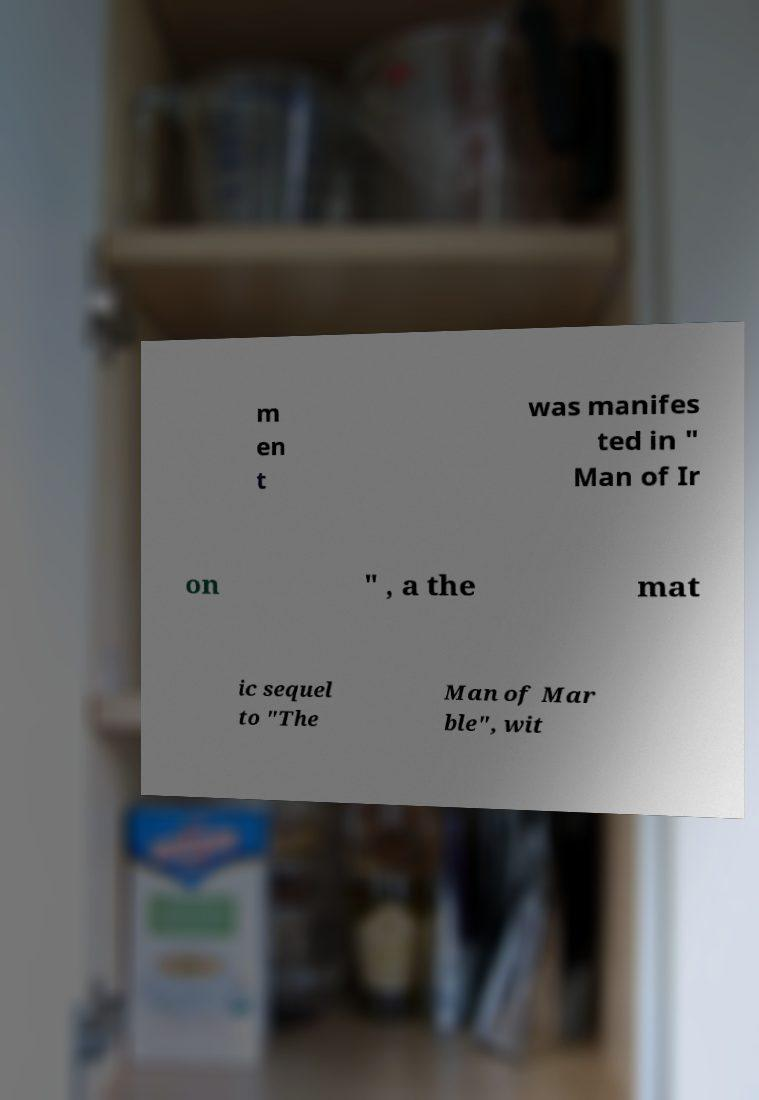Please identify and transcribe the text found in this image. m en t was manifes ted in " Man of Ir on " , a the mat ic sequel to "The Man of Mar ble", wit 